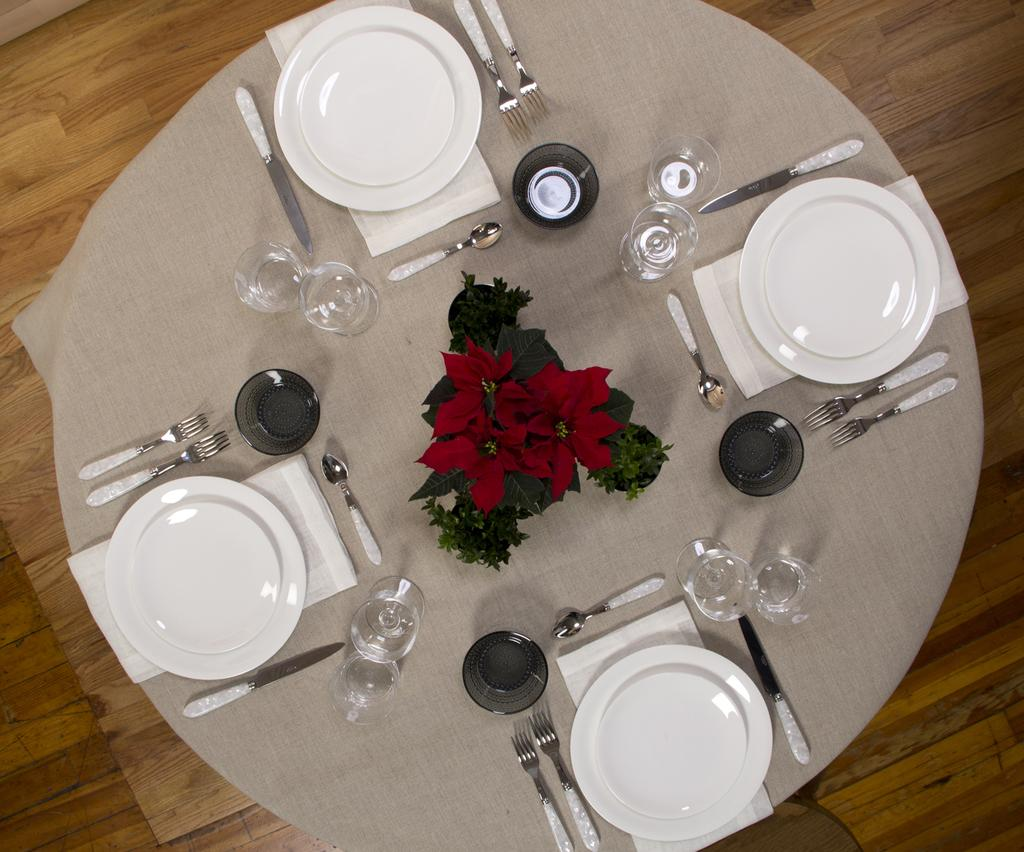What is located in the center of the image? There is a table in the center of the image. What items can be seen on the table? Plates, spoons, forks, tissue papers, glasses, a flower, and a plant are visible on the table. What utensils are present on the table? Spoons and forks are present on the table. What type of decoration is on the table? There is a flower and a plant on the table. What type of muscle is being exercised by the carpenter in the image? There is no carpenter present in the image, and therefore no muscle exercise can be observed. What type of flag is visible on the table in the image? There is no flag present on the table in the image. 